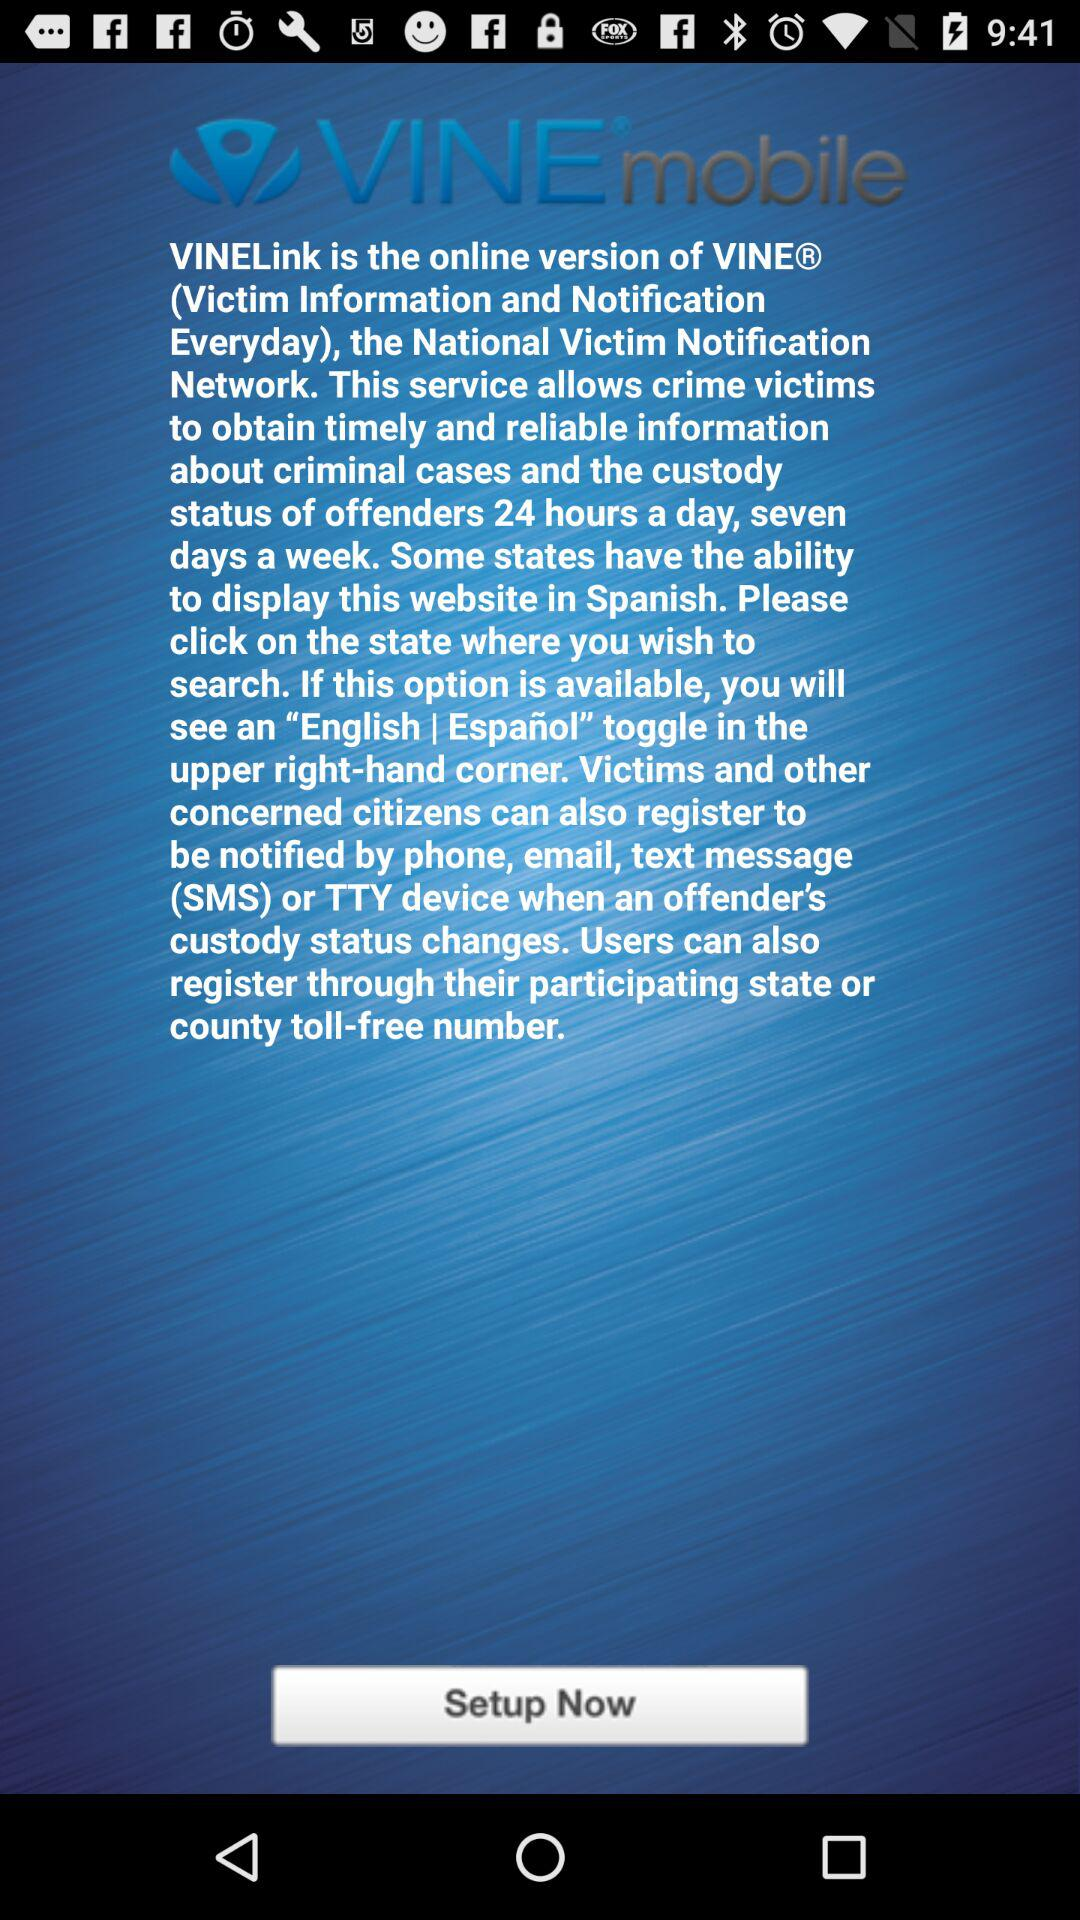What is the name of the application? The name of the application is "VINE®mobile". 